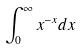<formula> <loc_0><loc_0><loc_500><loc_500>\int _ { 0 } ^ { \infty } x ^ { - x } d x</formula> 